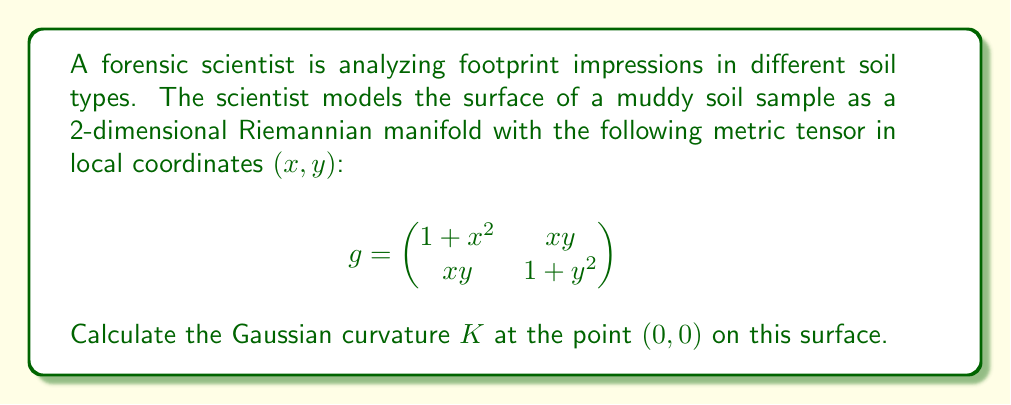What is the answer to this math problem? To calculate the Gaussian curvature $K$ at a point on a 2-dimensional Riemannian manifold, we need to use the following formula:

$$ K = \frac{R_{1212}}{det(g)} $$

Where $R_{1212}$ is the only independent component of the Riemann curvature tensor in 2D, and $det(g)$ is the determinant of the metric tensor.

Steps to solve:

1) First, we need to calculate the Christoffel symbols $\Gamma^k_{ij}$ using the formula:

   $$ \Gamma^k_{ij} = \frac{1}{2}g^{km}(\partial_i g_{jm} + \partial_j g_{im} - \partial_m g_{ij}) $$

2) We need to calculate the inverse metric $g^{ij}$:

   $$ g^{-1} = \frac{1}{det(g)} \begin{pmatrix}
   1 + y^2 & -xy \\
   -xy & 1 + x^2
   \end{pmatrix} $$

   Where $det(g) = (1+x^2)(1+y^2) - x^2y^2 = 1 + x^2 + y^2$

3) Calculate all non-zero Christoffel symbols at (0,0):

   $\Gamma^1_{11} = x, \Gamma^1_{12} = \Gamma^1_{21} = \frac{y}{2}, \Gamma^2_{12} = \Gamma^2_{21} = \frac{x}{2}, \Gamma^2_{22} = y$

   At (0,0), all Christoffel symbols are zero.

4) Calculate $R_{1212}$ using:

   $$ R_{1212} = \partial_1 \Gamma^2_{12} - \partial_2 \Gamma^2_{11} + \Gamma^k_{12}\Gamma^2_{k1} - \Gamma^k_{11}\Gamma^2_{k2} $$

   At (0,0): $R_{1212} = \frac{1}{2} - 0 + 0 - 0 = \frac{1}{2}$

5) Calculate $det(g)$ at (0,0):

   $det(g)|_{(0,0)} = 1$

6) Finally, calculate $K$:

   $$ K = \frac{R_{1212}}{det(g)} = \frac{1/2}{1} = \frac{1}{2} $$
Answer: The Gaussian curvature $K$ at the point $(0, 0)$ on the surface is $\frac{1}{2}$. 